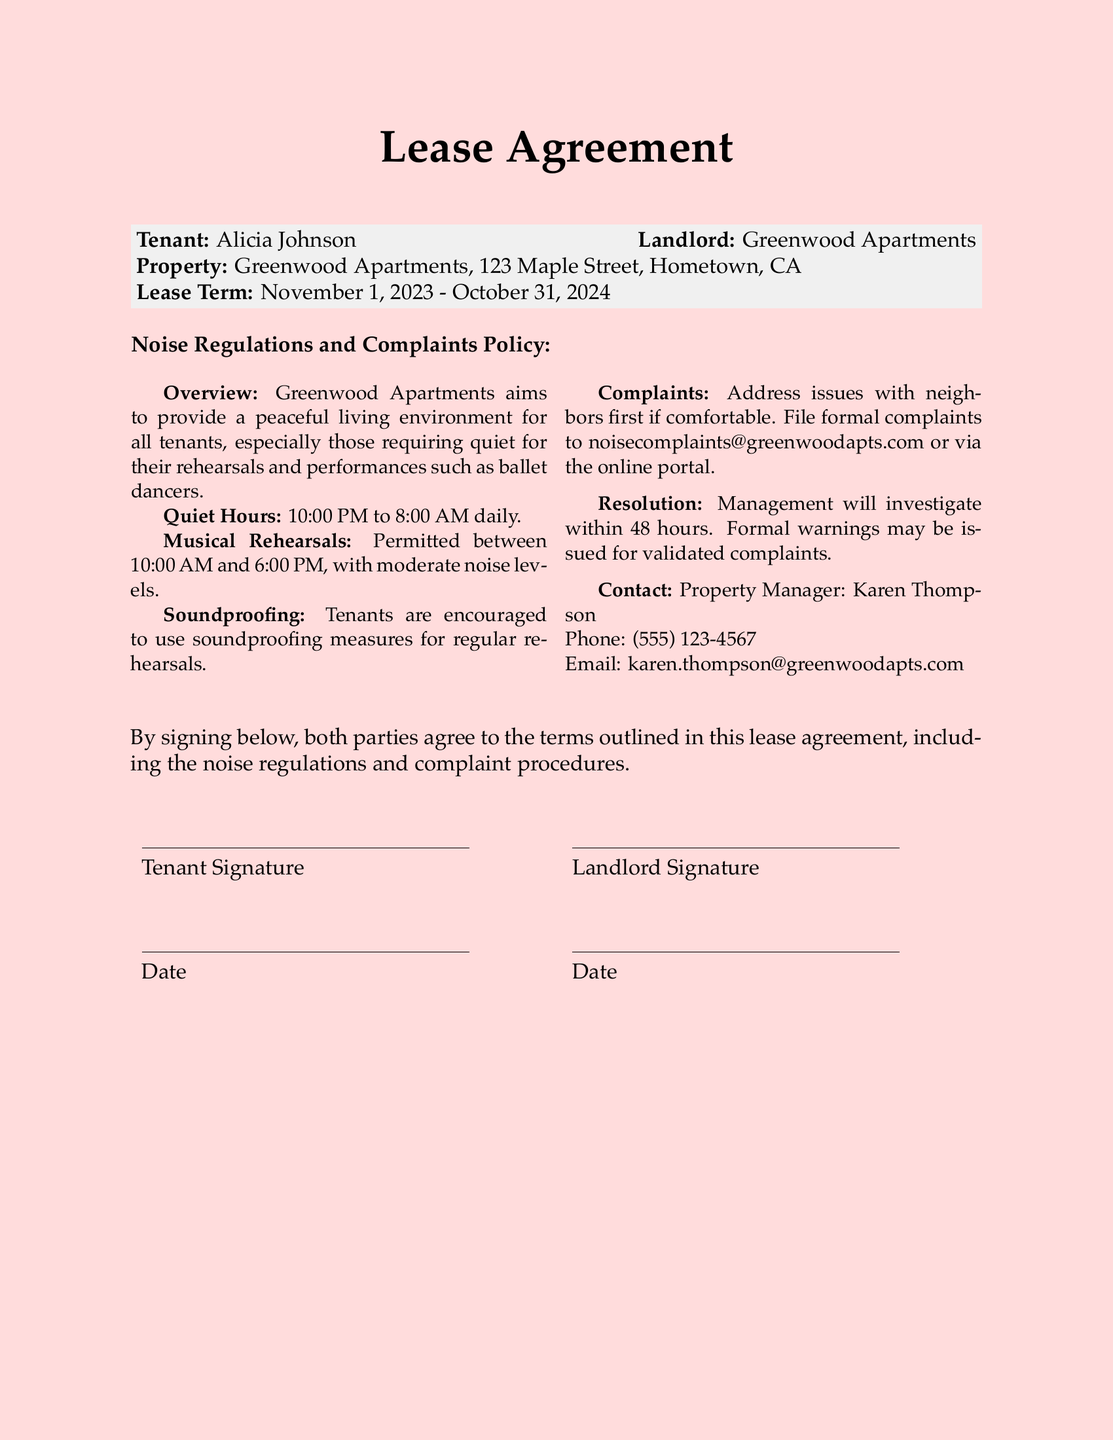What are the quiet hours? The lease agreement specifies quiet hours to maintain a peaceful living environment.
Answer: 10:00 PM to 8:00 AM What is permitted during musical rehearsals? The document outlines regulations for musical rehearsals, specifically mentioning conditions for noise levels.
Answer: Moderate noise levels Who is the property manager? The property manager is listed within the contact information section of the noise regulations policy.
Answer: Karen Thompson What should tenants do if there is a noise complaint? The document provides steps on how tenants should address noise complaints, emphasizing the preferred first step.
Answer: Address issues with neighbors first How long will management take to investigate complaints? The lease agreement specifies a timeframe within which management will act upon complaints.
Answer: 48 hours When is the lease term? The lease agreement contains specific dates indicating the start and end of the lease period.
Answer: November 1, 2023 - October 31, 2024 What is encouraged for regular rehearsals? The regulations suggest a specific measure to help minimize noise disruptions for rehearsals.
Answer: Soundproofing measures What email should complaints be sent to? The document includes a specific email address for formal noise complaints.
Answer: noisecomplaints@greenwoodapts.com 